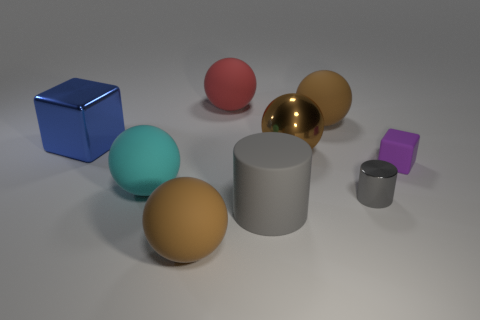How many blocks are either tiny objects or large blue shiny things?
Offer a terse response. 2. What number of large blue rubber balls are there?
Give a very brief answer. 0. There is a cube that is to the right of the brown matte ball that is on the left side of the large red matte ball; what is its size?
Provide a succinct answer. Small. What number of other things are the same size as the metallic cylinder?
Give a very brief answer. 1. What number of large brown matte spheres are in front of the big blue shiny thing?
Ensure brevity in your answer.  1. The cyan matte thing is what size?
Give a very brief answer. Large. Does the gray object left of the metallic cylinder have the same material as the cube to the left of the small cylinder?
Offer a very short reply. No. Is there a large rubber cylinder of the same color as the tiny metal cylinder?
Offer a terse response. Yes. The cube that is the same size as the gray matte object is what color?
Offer a terse response. Blue. Do the rubber cylinder right of the metallic block and the tiny shiny cylinder have the same color?
Provide a succinct answer. Yes. 